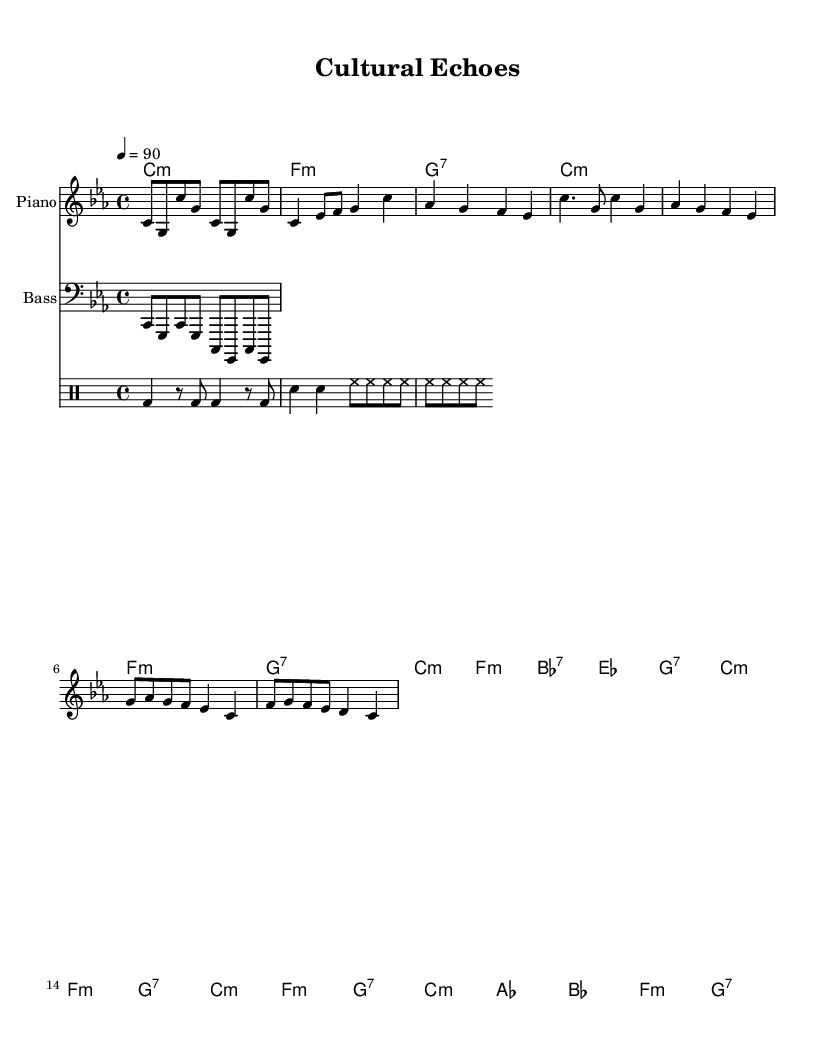What is the key signature of this music? The key signature is C minor, which is represented by three flats in the key signature.
Answer: C minor What is the time signature of this music? The time signature is indicated as 4/4, meaning there are four beats in a measure and the quarter note gets one beat.
Answer: 4/4 What is the tempo marking for this piece? The tempo marking is set at 90 beats per minute, indicated by the marking above the staff.
Answer: 90 How many measures are in the verse section? Counting the measures in the verse section, there are eight measures as indicated by the structure of the music.
Answer: 8 What chord follows the F minor chord in the verse? The chord following the F minor chord is G7, as shown in the chord progression.
Answer: G7 Which instrument plays the bass line in this piece? The bass line is played by the "Bass" staff shown in the score, which is specifically labeled as such.
Answer: Bass What type of rhythmic pattern is used in the drums part? The drums part includes a kick-drum (bd), snare (sn), and hi-hat (hh), creating a traditional hip-hop rhythmic feel.
Answer: Hip-hop rhythm 